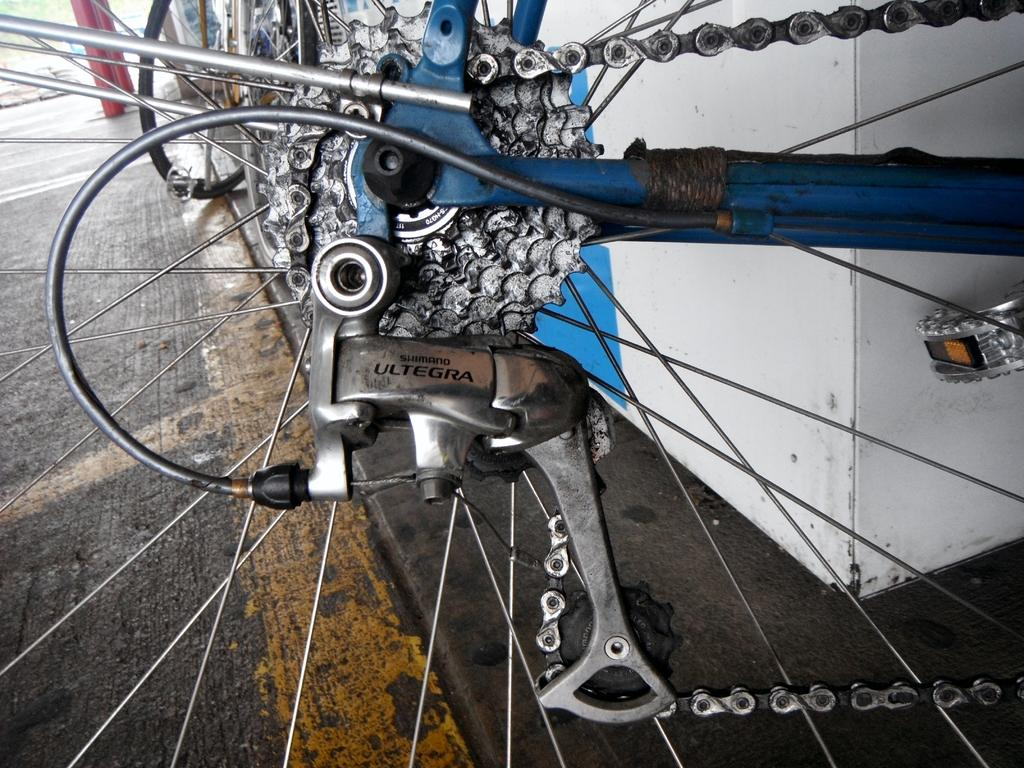What is the main object in the image? There is a bicycle wheel in the image. What colors can be seen on the bicycle wheel? The bicycle wheel has silver and blue colors. What type of vegetation is visible to the left of the image? There is grass visible to the left of the image. Where is the thumb located in the image? There is no thumb present in the image. What type of food is being served in the lunchroom in the image? There is no lunchroom present in the image. 